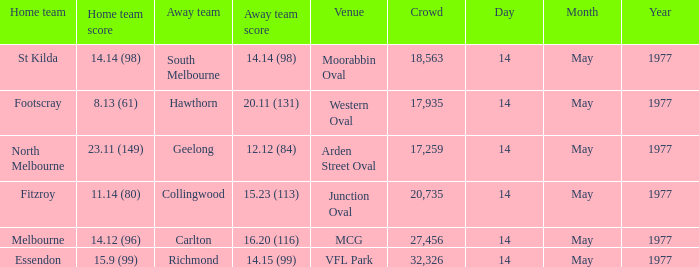Name the away team for essendon Richmond. 